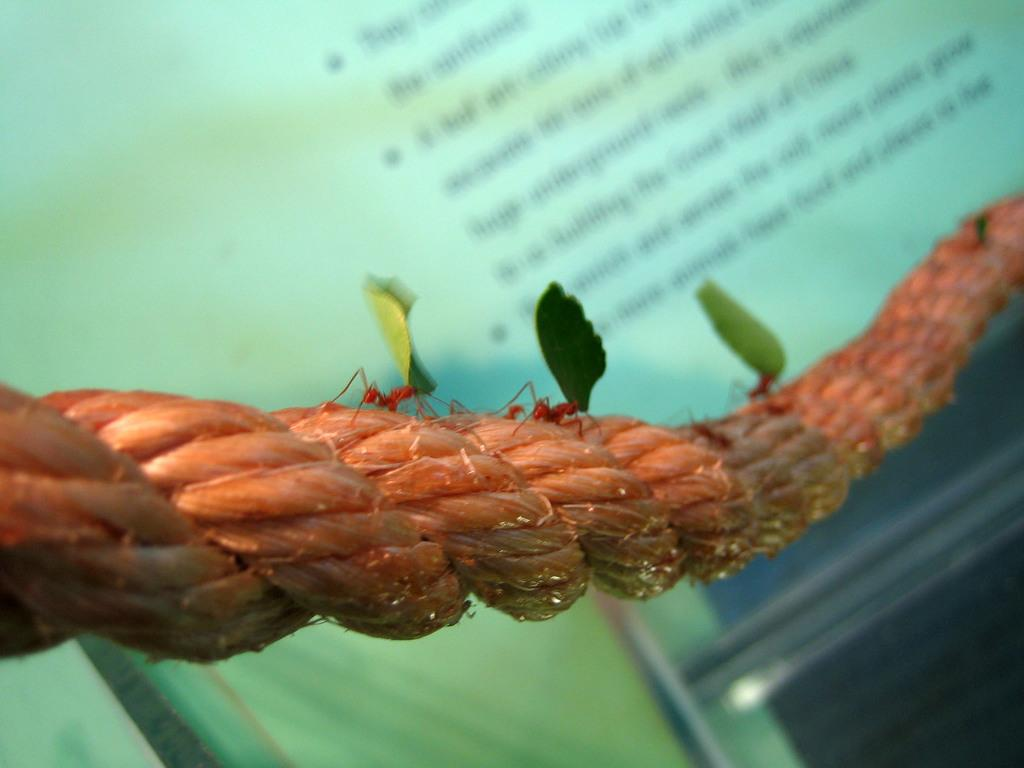What is one of the objects in the image? There is a rope in the image. What type of small creatures can be seen in the image? There are ants in the image. What natural elements are present in the image? There are leaves in the image. How would you describe the background of the image? The background of the image has a blurred view. Is there any written content visible in the image? Yes, there is some text visible in the image. What other object can be seen in the image? There is a rod in the image. Can you tell me how many bears are walking on the trail in the image? There are no bears or trails present in the image. What type of prose is written on the leaves in the image? There is no prose written on the leaves in the image; there are only ants and leaves visible. 